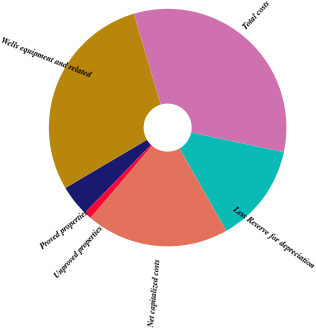Convert chart. <chart><loc_0><loc_0><loc_500><loc_500><pie_chart><fcel>Unproved properties<fcel>Proved properties<fcel>Wells equipment and related<fcel>Total costs<fcel>Less Reserve for depreciation<fcel>Net capitalized costs<nl><fcel>1.04%<fcel>4.23%<fcel>28.89%<fcel>32.92%<fcel>13.45%<fcel>19.47%<nl></chart> 